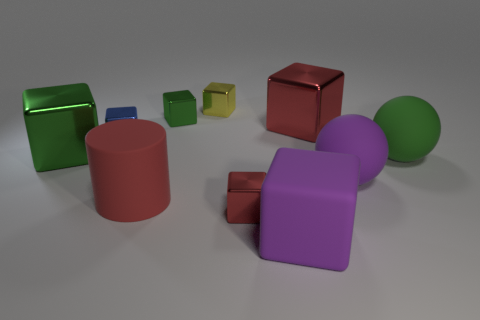What is the shape of the small object that is the same color as the large cylinder?
Provide a succinct answer. Cube. How many objects are either objects in front of the large red cylinder or matte blocks?
Make the answer very short. 2. Is the red cylinder the same size as the yellow object?
Ensure brevity in your answer.  No. What color is the tiny shiny object to the right of the yellow metallic object?
Ensure brevity in your answer.  Red. What size is the yellow cube that is made of the same material as the large red block?
Ensure brevity in your answer.  Small. Do the red matte cylinder and the green object right of the yellow metal cube have the same size?
Keep it short and to the point. Yes. What is the material of the big green thing behind the green rubber object?
Ensure brevity in your answer.  Metal. There is a matte thing to the left of the tiny yellow metallic block; what number of green rubber spheres are left of it?
Ensure brevity in your answer.  0. Are there any gray objects of the same shape as the green matte thing?
Make the answer very short. No. There is a yellow object to the right of the matte cylinder; does it have the same size as the green shiny object that is in front of the big red shiny object?
Your answer should be compact. No. 